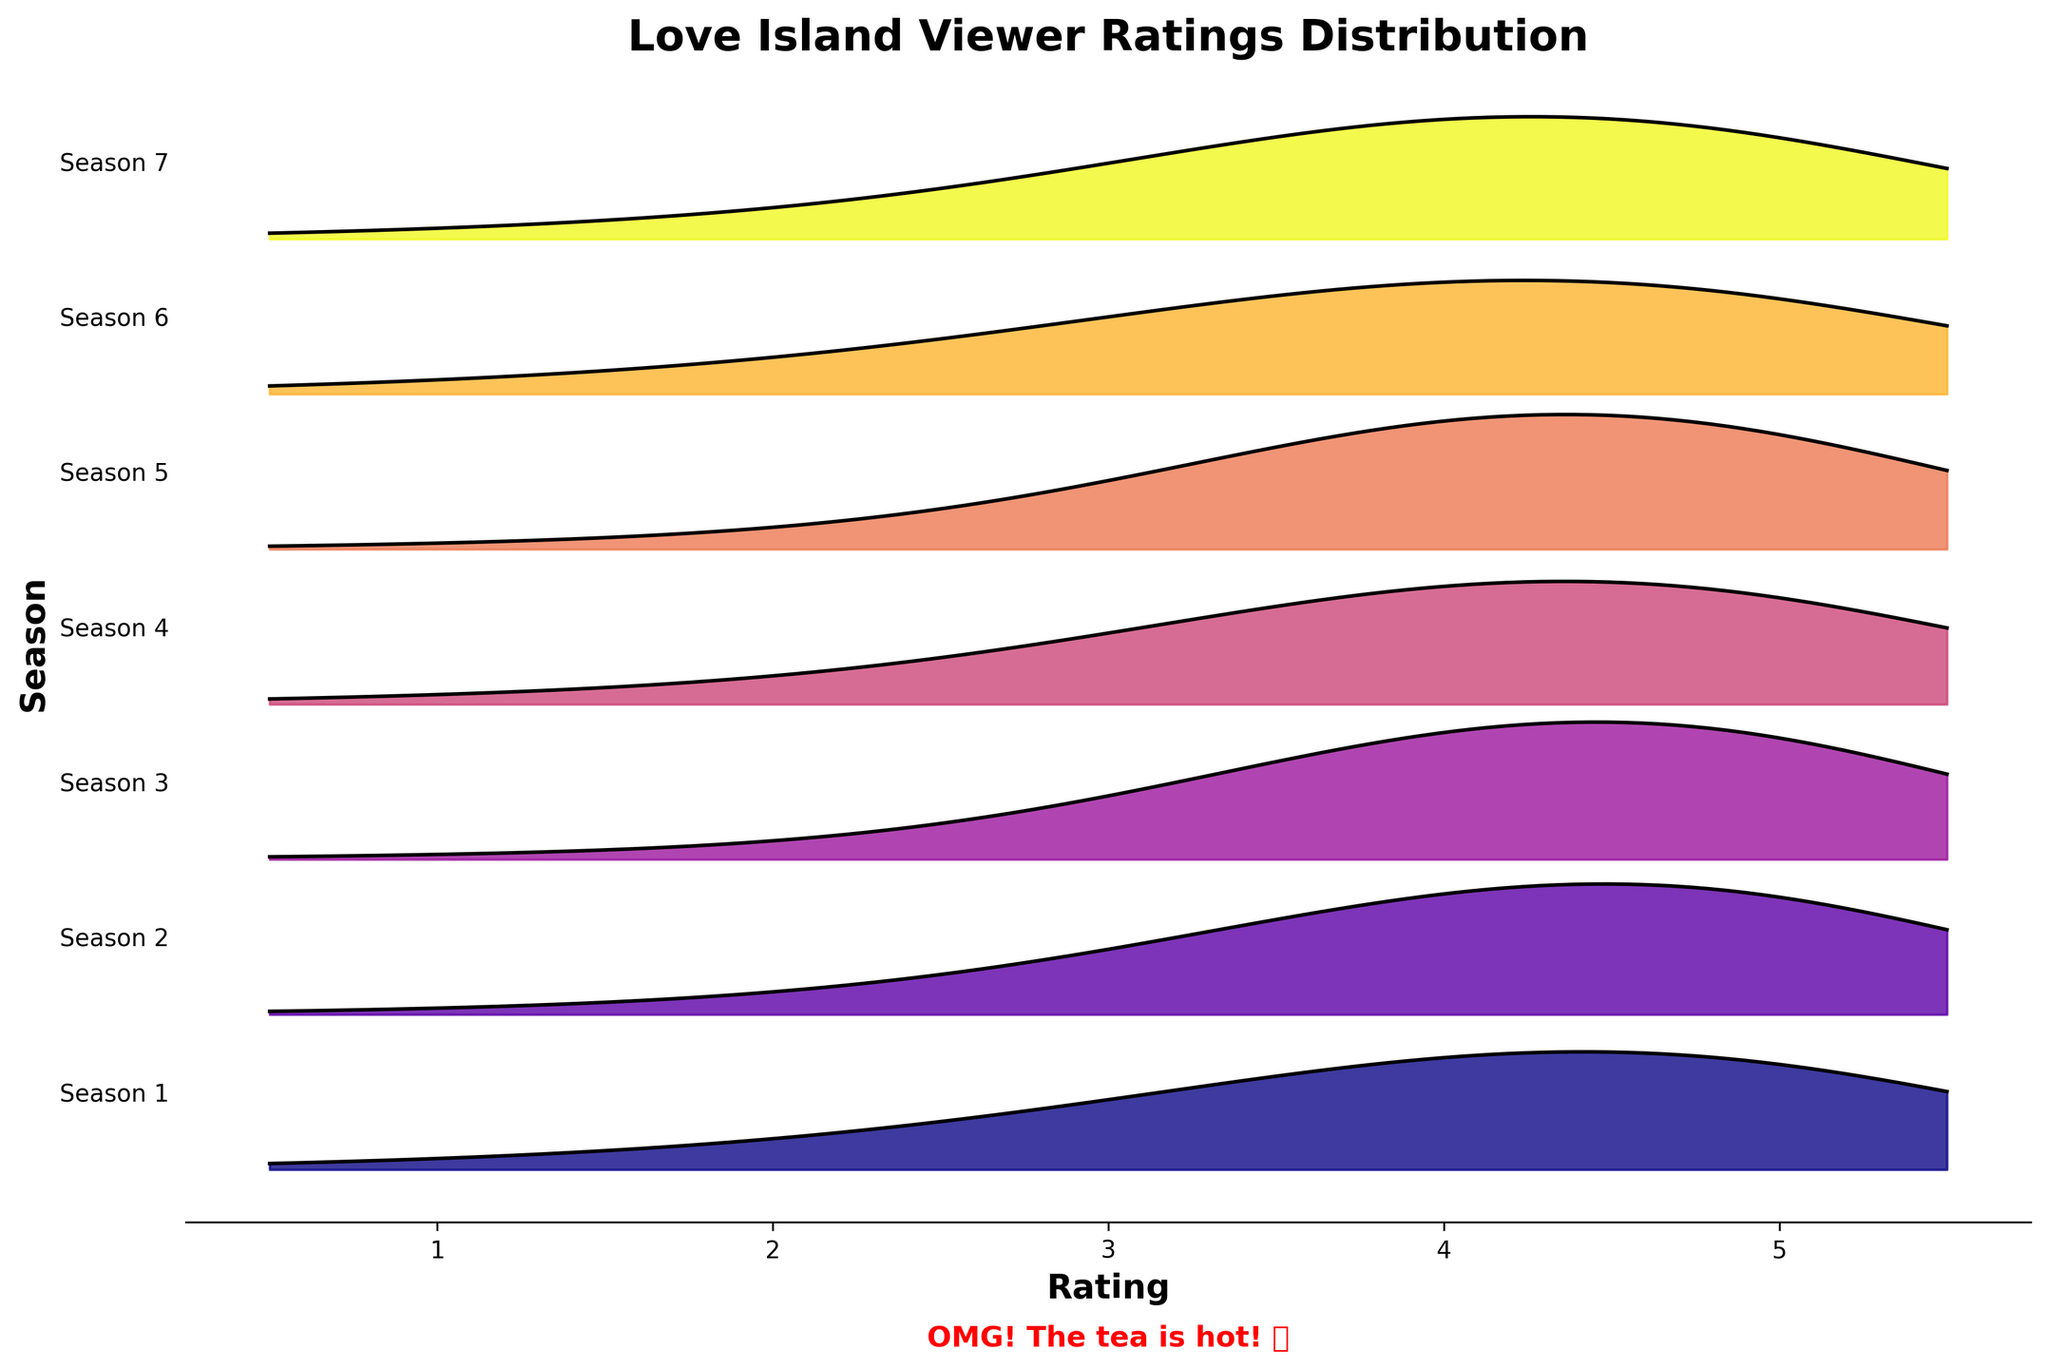What is the title of this plot? The title should be written at the top of the plot. It states what the plot is about.
Answer: Love Island Viewer Ratings Distribution How many seasons are displayed in the plot? The y-axis labels represent different seasons. Count the distinct labels to find the number of seasons.
Answer: 7 Which season has the highest density of 5-star ratings? Look at the density lines position corresponding to the '5' rating and identify the season with the highest peak.
Answer: Season 2 In which season do we see the least density at a 1-star rating? Examine the density line at the '1' rating level and find the season with the lowest value.
Answer: Season 2 Compare the density of 4-star ratings in Season 4 and Season 6. Which has a higher density? Look at the position of the density lines at the '4' rating for Season 4 and Season 6, and identify which one is higher.
Answer: Season 6 Which seasons have an equal density for the 5-star rating? Compare the density values for the '5' rating across all seasons. Identify the seasons where the densities match.
Answer: Season 4 and Season 5 What is the general trend for viewer ratings across all seasons? Examine the peaks and spreads of the densities for each season. Summarize the common trend across all seasons.
Answer: Most viewers rate 4 or 5 stars By how much does the density of 4-star ratings in Season 1 exceed that of Season 7? Look at the density value at the '4' rating for both Season 1 and Season 7 and subtract the density of Season 7 from Season 1.
Answer: 0.05 How does the density of 3-star ratings in Season 3 compare to Season 7? Compare the height of the density curves at the '3' rating level for Season 3 and Season 7. Identify which one is higher.
Answer: Season 7 Which season has the widest spread in viewer ratings from 1 to 5 stars? Observe how widely the density spreads from 1 to 5 stars for each season, and choose the season with the broadest spread.
Answer: Season 6 